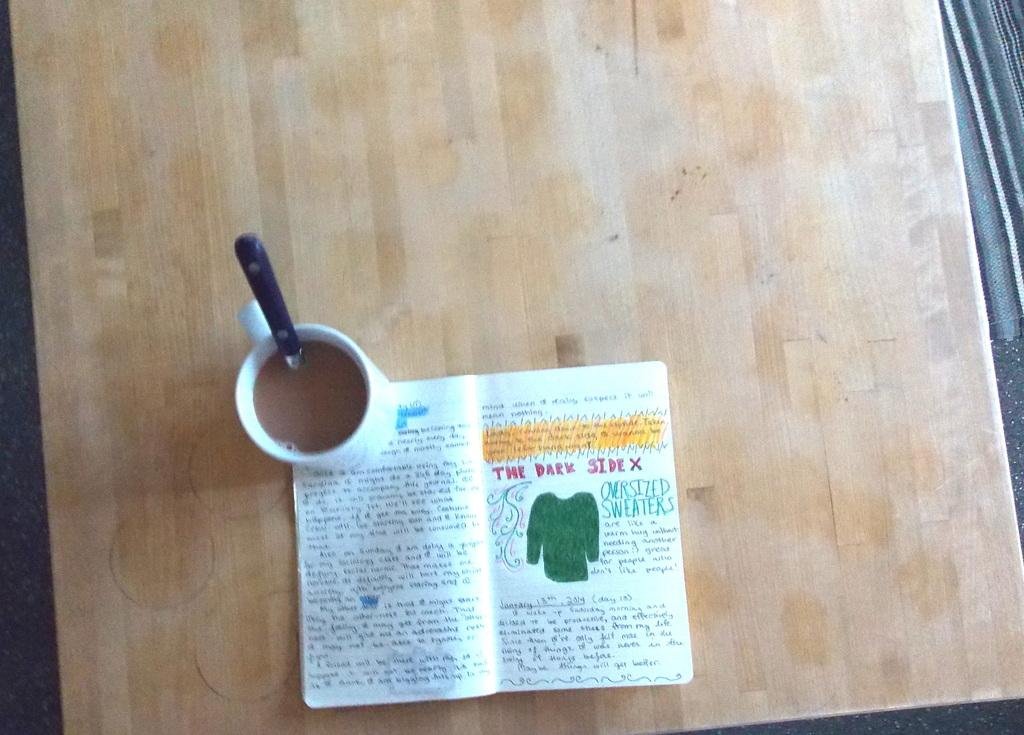<image>
Write a terse but informative summary of the picture. A mug of coffee is holding open a notebook that says The Dark Side. 